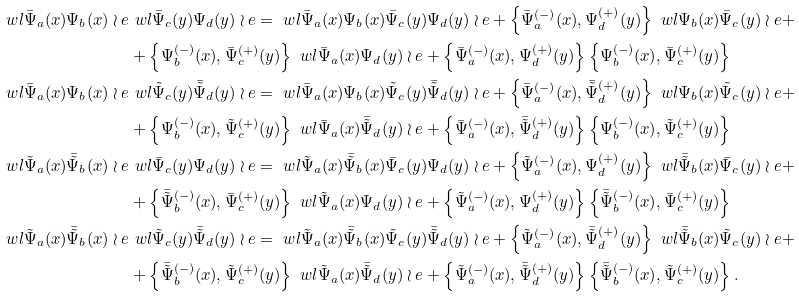Convert formula to latex. <formula><loc_0><loc_0><loc_500><loc_500>\ w l \bar { \Psi } _ { a } ( x ) \Psi _ { b } ( x ) \wr e & \ w l \bar { \Psi } _ { c } ( y ) \Psi _ { d } ( y ) \wr e = \ w l \bar { \Psi } _ { a } ( x ) \Psi _ { b } ( x ) \bar { \Psi } _ { c } ( y ) \Psi _ { d } ( y ) \wr e + \left \{ \bar { \Psi } _ { a } ^ { ( - ) } ( x ) , \Psi _ { d } ^ { ( + ) } ( y ) \right \} \ w l \Psi _ { b } ( x ) \bar { \Psi } _ { c } ( y ) \wr e + \\ & + \left \{ \Psi _ { b } ^ { ( - ) } ( x ) , \bar { \Psi } _ { c } ^ { ( + ) } ( y ) \right \} \ w l \bar { \Psi } _ { a } ( x ) \Psi _ { d } ( y ) \wr e + \left \{ \bar { \Psi } _ { a } ^ { ( - ) } ( x ) , \Psi _ { d } ^ { ( + ) } ( y ) \right \} \left \{ \Psi _ { b } ^ { ( - ) } ( x ) , \bar { \Psi } _ { c } ^ { ( + ) } ( y ) \right \} \\ \ w l \bar { \Psi } _ { a } ( x ) \Psi _ { b } ( x ) \wr e & \ w l \tilde { \Psi } _ { c } ( y ) \bar { \tilde { \Psi } } _ { d } ( y ) \wr e = \ w l \bar { \Psi } _ { a } ( x ) \Psi _ { b } ( x ) \tilde { \Psi } _ { c } ( y ) \bar { \tilde { \Psi } } _ { d } ( y ) \wr e + \left \{ \bar { \Psi } _ { a } ^ { ( - ) } ( x ) , \bar { \tilde { \Psi } } _ { d } ^ { ( + ) } ( y ) \right \} \ w l \Psi _ { b } ( x ) \tilde { \Psi } _ { c } ( y ) \wr e + \\ & + \left \{ \Psi _ { b } ^ { ( - ) } ( x ) , \tilde { \Psi } _ { c } ^ { ( + ) } ( y ) \right \} \ w l \bar { \Psi } _ { a } ( x ) \bar { \tilde { \Psi } } _ { d } ( y ) \wr e + \left \{ \bar { \Psi } _ { a } ^ { ( - ) } ( x ) , \bar { \tilde { \Psi } } _ { d } ^ { ( + ) } ( y ) \right \} \left \{ \Psi _ { b } ^ { ( - ) } ( x ) , \tilde { \Psi } _ { c } ^ { ( + ) } ( y ) \right \} \\ \ w l \tilde { \Psi } _ { a } ( x ) \bar { \tilde { \Psi } } _ { b } ( x ) \wr e & \ w l \bar { \Psi } _ { c } ( y ) \Psi _ { d } ( y ) \wr e = \ w l \tilde { \Psi } _ { a } ( x ) \bar { \tilde { \Psi } } _ { b } ( x ) \bar { \Psi } _ { c } ( y ) \Psi _ { d } ( y ) \wr e + \left \{ \tilde { \Psi } _ { a } ^ { ( - ) } ( x ) , \Psi _ { d } ^ { ( + ) } ( y ) \right \} \ w l \bar { \tilde { \Psi } } _ { b } ( x ) \bar { \Psi } _ { c } ( y ) \wr e + \\ & + \left \{ \bar { \tilde { \Psi } } _ { b } ^ { ( - ) } ( x ) , \bar { \Psi } _ { c } ^ { ( + ) } ( y ) \right \} \ w l \tilde { \Psi } _ { a } ( x ) \Psi _ { d } ( y ) \wr e + \left \{ \tilde { \Psi } _ { a } ^ { ( - ) } ( x ) , \Psi _ { d } ^ { ( + ) } ( y ) \right \} \left \{ \bar { \tilde { \Psi } } _ { b } ^ { ( - ) } ( x ) , \bar { \Psi } _ { c } ^ { ( + ) } ( y ) \right \} \\ \ w l \tilde { \Psi } _ { a } ( x ) \bar { \tilde { \Psi } } _ { b } ( x ) \wr e & \ w l \tilde { \Psi } _ { c } ( y ) \bar { \tilde { \Psi } } _ { d } ( y ) \wr e = \ w l \tilde { \Psi } _ { a } ( x ) \bar { \tilde { \Psi } } _ { b } ( x ) \tilde { \Psi } _ { c } ( y ) \bar { \tilde { \Psi } } _ { d } ( y ) \wr e + \left \{ \tilde { \Psi } _ { a } ^ { ( - ) } ( x ) , \bar { \tilde { \Psi } } _ { d } ^ { ( + ) } ( y ) \right \} \ w l \bar { \tilde { \Psi } } _ { b } ( x ) \tilde { \Psi } _ { c } ( y ) \wr e + \\ & + \left \{ \bar { \tilde { \Psi } } _ { b } ^ { ( - ) } ( x ) , \tilde { \Psi } _ { c } ^ { ( + ) } ( y ) \right \} \ w l \tilde { \Psi } _ { a } ( x ) \bar { \tilde { \Psi } } _ { d } ( y ) \wr e + \left \{ \tilde { \Psi } _ { a } ^ { ( - ) } ( x ) , \bar { \tilde { \Psi } } _ { d } ^ { ( + ) } ( y ) \right \} \left \{ \bar { \tilde { \Psi } } _ { b } ^ { ( - ) } ( x ) , \tilde { \Psi } _ { c } ^ { ( + ) } ( y ) \right \} .</formula> 